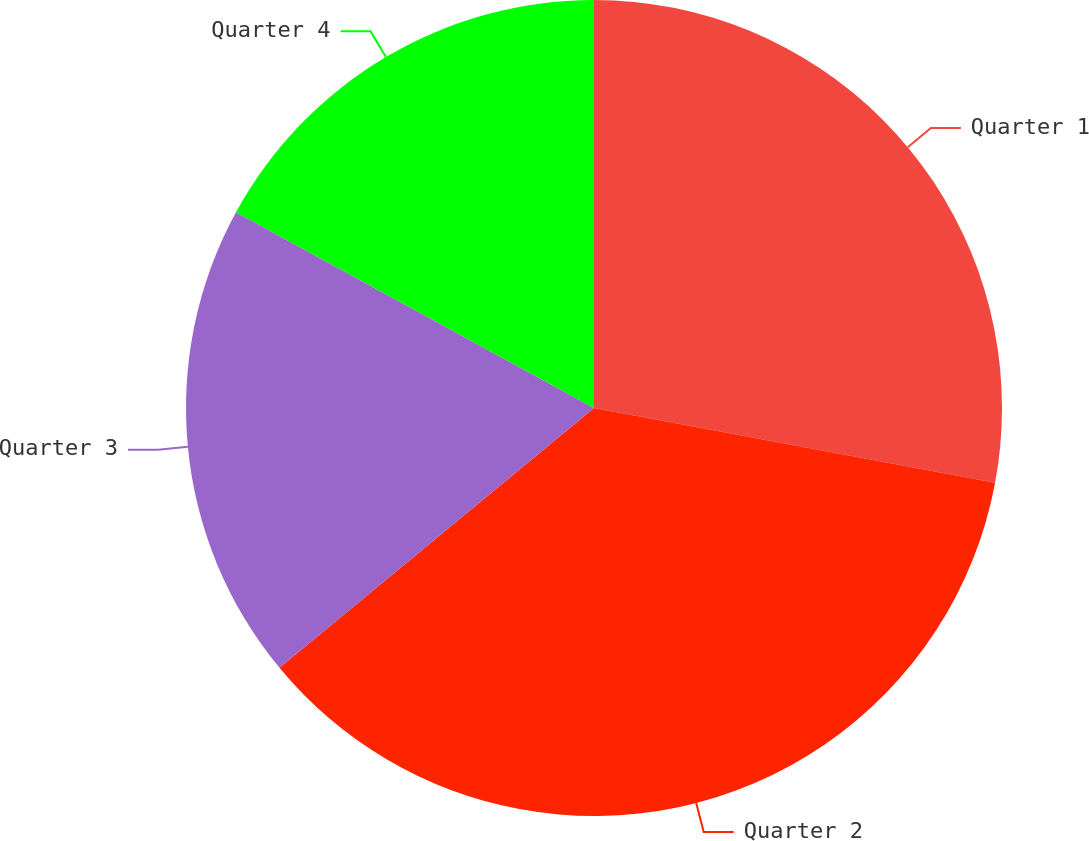Convert chart to OTSL. <chart><loc_0><loc_0><loc_500><loc_500><pie_chart><fcel>Quarter 1<fcel>Quarter 2<fcel>Quarter 3<fcel>Quarter 4<nl><fcel>27.93%<fcel>36.08%<fcel>18.95%<fcel>17.04%<nl></chart> 